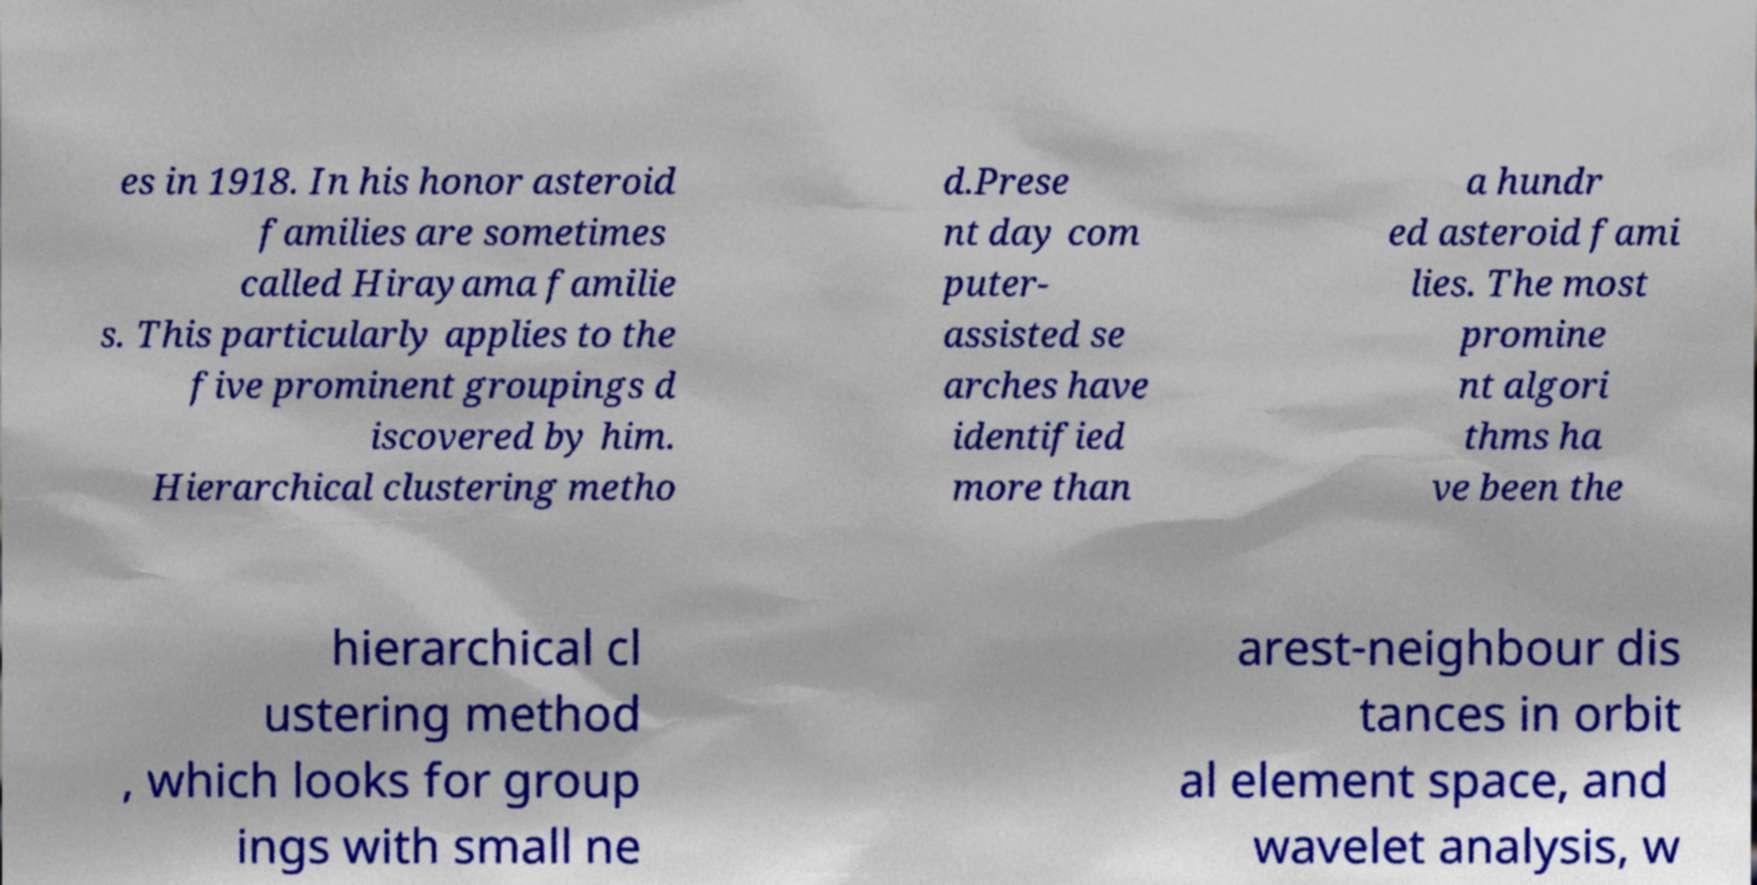There's text embedded in this image that I need extracted. Can you transcribe it verbatim? es in 1918. In his honor asteroid families are sometimes called Hirayama familie s. This particularly applies to the five prominent groupings d iscovered by him. Hierarchical clustering metho d.Prese nt day com puter- assisted se arches have identified more than a hundr ed asteroid fami lies. The most promine nt algori thms ha ve been the hierarchical cl ustering method , which looks for group ings with small ne arest-neighbour dis tances in orbit al element space, and wavelet analysis, w 